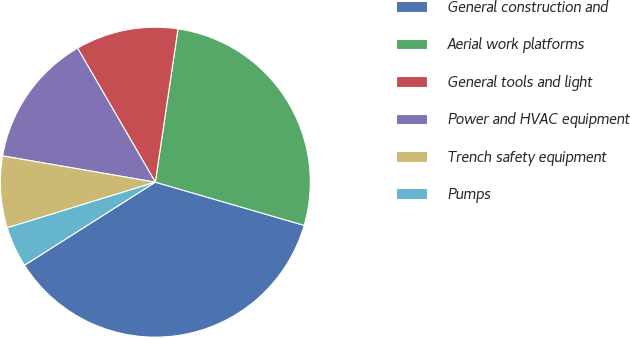Convert chart to OTSL. <chart><loc_0><loc_0><loc_500><loc_500><pie_chart><fcel>General construction and<fcel>Aerial work platforms<fcel>General tools and light<fcel>Power and HVAC equipment<fcel>Trench safety equipment<fcel>Pumps<nl><fcel>36.5%<fcel>27.16%<fcel>10.7%<fcel>13.92%<fcel>7.47%<fcel>4.24%<nl></chart> 